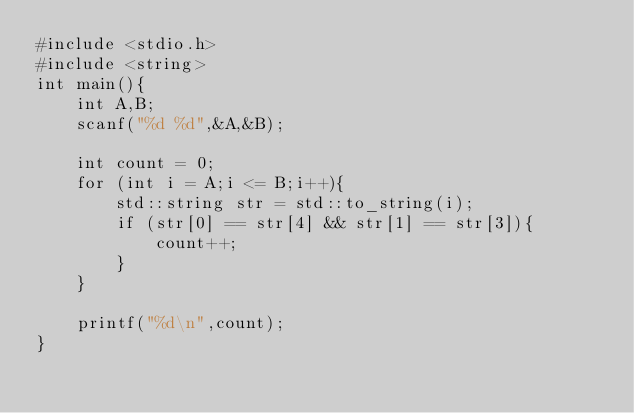<code> <loc_0><loc_0><loc_500><loc_500><_C++_>#include <stdio.h>
#include <string>
int main(){
    int A,B;
    scanf("%d %d",&A,&B);

    int count = 0;
    for (int i = A;i <= B;i++){
        std::string str = std::to_string(i);
        if (str[0] == str[4] && str[1] == str[3]){
            count++;
        }
    }

    printf("%d\n",count);
}</code> 